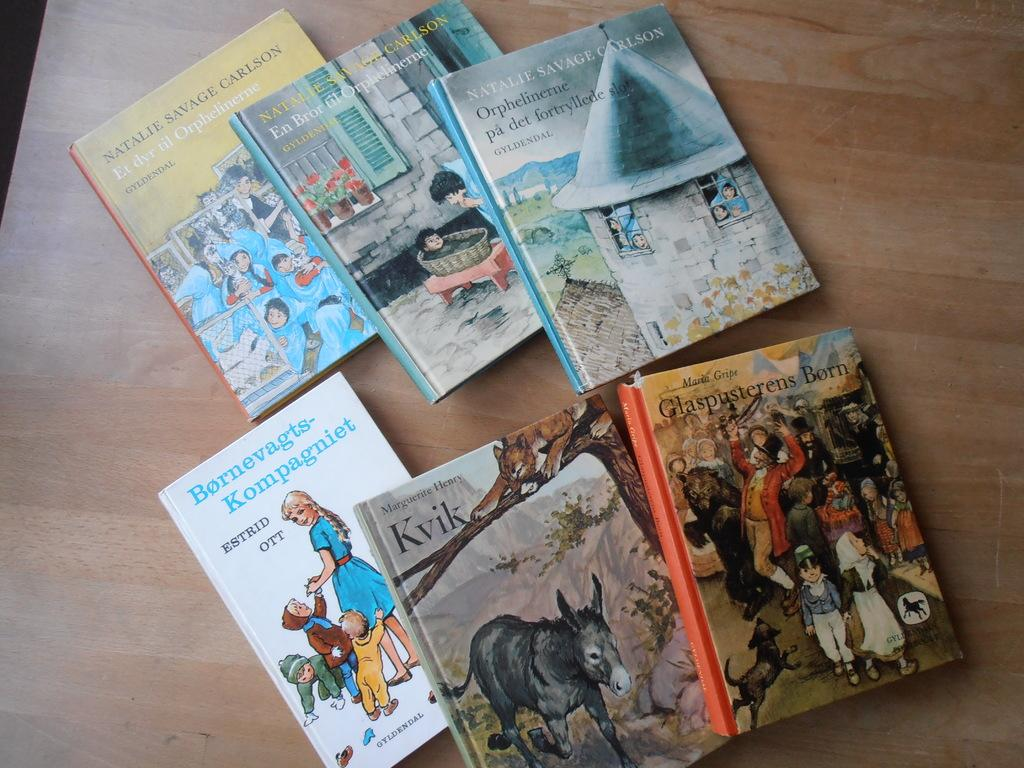<image>
Present a compact description of the photo's key features. A number of foreign language books, one of which is by someone named Estrid Ott. 